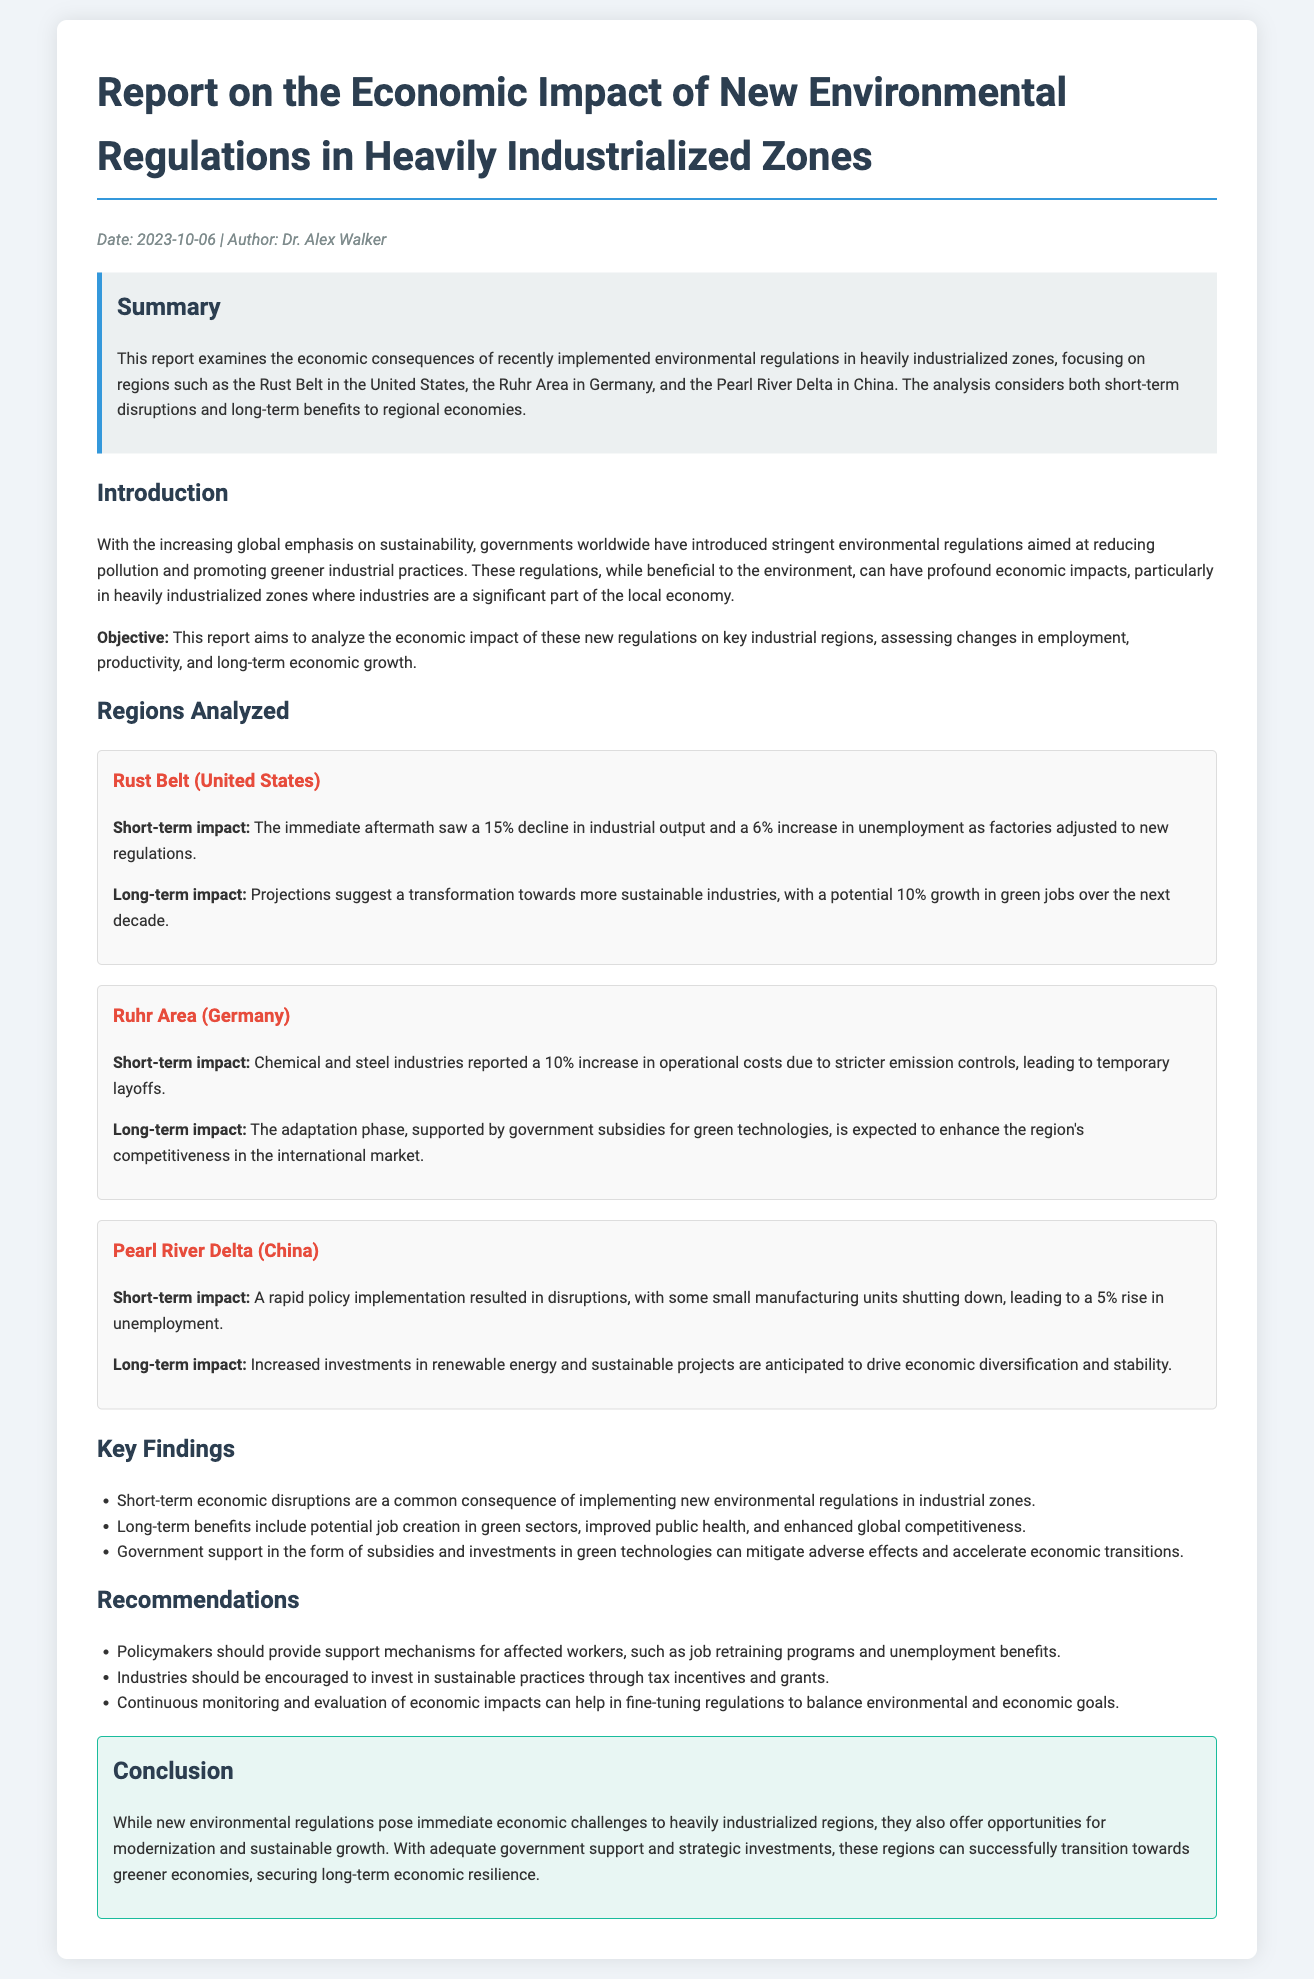What is the title of the report? The title is mentioned at the top of the document as "Report on the Economic Impact of New Environmental Regulations in Heavily Industrialized Zones".
Answer: Report on the Economic Impact of New Environmental Regulations in Heavily Industrialized Zones Who is the author of the report? The author is listed in the metadata section of the document.
Answer: Dr. Alex Walker What was the short-term impact in the Rust Belt? The document specifies that the immediate aftermath saw a 15% decline in industrial output and a 6% increase in unemployment.
Answer: 15% decline in industrial output and 6% increase in unemployment Which region reported a 10% increase in operational costs? The document indicates that the Ruhr Area in Germany reported this increase due to stricter emission controls.
Answer: Ruhr Area (Germany) What is one key finding of the report? The document lists several key findings, one being that short-term economic disruptions are a common consequence of implementing new regulations.
Answer: Short-term economic disruptions are a common consequence What does the report recommend for affected workers? The recommendations section includes providing support mechanisms for affected workers, such as job retraining programs.
Answer: Job retraining programs What is the anticipated long-term impact in the Pearl River Delta? The document concludes that increased investments in renewable energy and sustainable projects are expected to drive economic diversification.
Answer: Economic diversification What are the main regions analyzed in the report? The regions analyzed include the Rust Belt, Ruhr Area, and Pearl River Delta, which are mentioned explicitly in the introduction.
Answer: Rust Belt, Ruhr Area, Pearl River Delta 